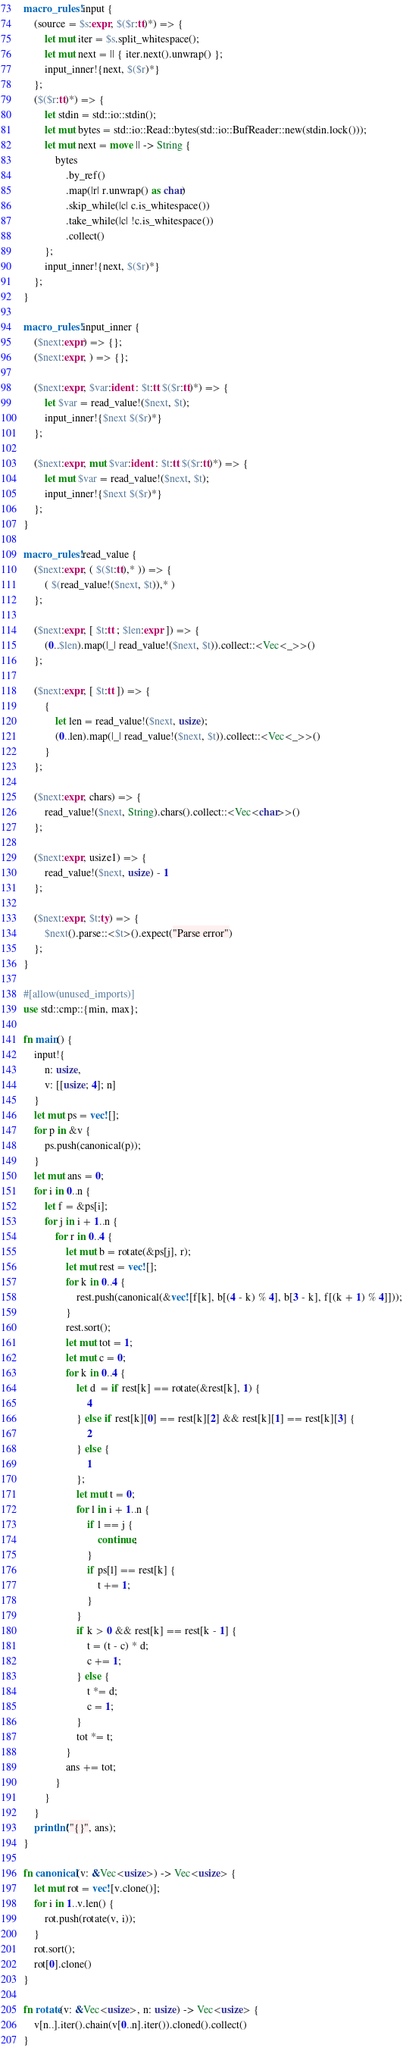Convert code to text. <code><loc_0><loc_0><loc_500><loc_500><_Rust_>macro_rules! input {
    (source = $s:expr, $($r:tt)*) => {
        let mut iter = $s.split_whitespace();
        let mut next = || { iter.next().unwrap() };
        input_inner!{next, $($r)*}
    };
    ($($r:tt)*) => {
        let stdin = std::io::stdin();
        let mut bytes = std::io::Read::bytes(std::io::BufReader::new(stdin.lock()));
        let mut next = move || -> String {
            bytes
                .by_ref()
                .map(|r| r.unwrap() as char)
                .skip_while(|c| c.is_whitespace())
                .take_while(|c| !c.is_whitespace())
                .collect()
        };
        input_inner!{next, $($r)*}
    };
}

macro_rules! input_inner {
    ($next:expr) => {};
    ($next:expr, ) => {};

    ($next:expr, $var:ident : $t:tt $($r:tt)*) => {
        let $var = read_value!($next, $t);
        input_inner!{$next $($r)*}
    };

    ($next:expr, mut $var:ident : $t:tt $($r:tt)*) => {
        let mut $var = read_value!($next, $t);
        input_inner!{$next $($r)*}
    };
}

macro_rules! read_value {
    ($next:expr, ( $($t:tt),* )) => {
        ( $(read_value!($next, $t)),* )
    };

    ($next:expr, [ $t:tt ; $len:expr ]) => {
        (0..$len).map(|_| read_value!($next, $t)).collect::<Vec<_>>()
    };

    ($next:expr, [ $t:tt ]) => {
        {
            let len = read_value!($next, usize);
            (0..len).map(|_| read_value!($next, $t)).collect::<Vec<_>>()
        }
    };

    ($next:expr, chars) => {
        read_value!($next, String).chars().collect::<Vec<char>>()
    };

    ($next:expr, usize1) => {
        read_value!($next, usize) - 1
    };

    ($next:expr, $t:ty) => {
        $next().parse::<$t>().expect("Parse error")
    };
}

#[allow(unused_imports)]
use std::cmp::{min, max};

fn main() {
    input!{
        n: usize,
        v: [[usize; 4]; n]
    }
    let mut ps = vec![];
    for p in &v {
        ps.push(canonical(p));
    }
    let mut ans = 0;
    for i in 0..n {
        let f = &ps[i];
        for j in i + 1..n {
            for r in 0..4 {
                let mut b = rotate(&ps[j], r);
                let mut rest = vec![];
                for k in 0..4 {
                    rest.push(canonical(&vec![f[k], b[(4 - k) % 4], b[3 - k], f[(k + 1) % 4]]));
                }
                rest.sort();
                let mut tot = 1;
                let mut c = 0;
                for k in 0..4 {
                    let d  = if rest[k] == rotate(&rest[k], 1) {
                        4
                    } else if rest[k][0] == rest[k][2] && rest[k][1] == rest[k][3] {
                        2
                    } else {
                        1
                    };
                    let mut t = 0;
                    for l in i + 1..n {
                        if l == j {
                            continue;
                        }
                        if ps[l] == rest[k] {
                            t += 1;
                        }
                    }
                    if k > 0 && rest[k] == rest[k - 1] {
                        t = (t - c) * d;
                        c += 1;
                    } else {
                        t *= d;
                        c = 1;
                    }
                    tot *= t;
                }
                ans += tot;
            }
        }
    }
    println!("{}", ans);
}

fn canonical(v: &Vec<usize>) -> Vec<usize> {
    let mut rot = vec![v.clone()];
    for i in 1..v.len() {
        rot.push(rotate(v, i));
    }
    rot.sort();
    rot[0].clone()
}

fn rotate(v: &Vec<usize>, n: usize) -> Vec<usize> {
    v[n..].iter().chain(v[0..n].iter()).cloned().collect()
}
</code> 